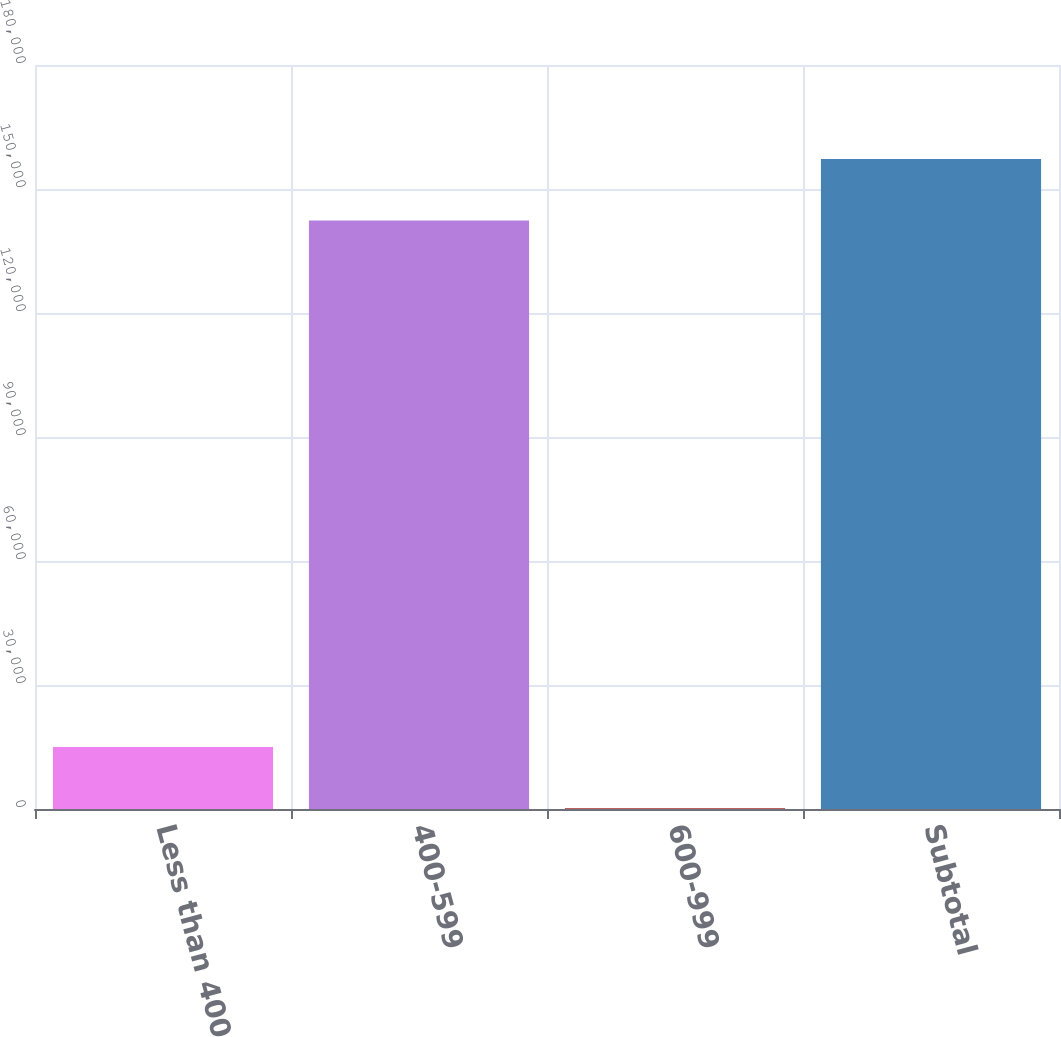Convert chart. <chart><loc_0><loc_0><loc_500><loc_500><bar_chart><fcel>Less than 400<fcel>400-599<fcel>600-999<fcel>Subtotal<nl><fcel>15006.6<fcel>142402<fcel>158<fcel>157251<nl></chart> 